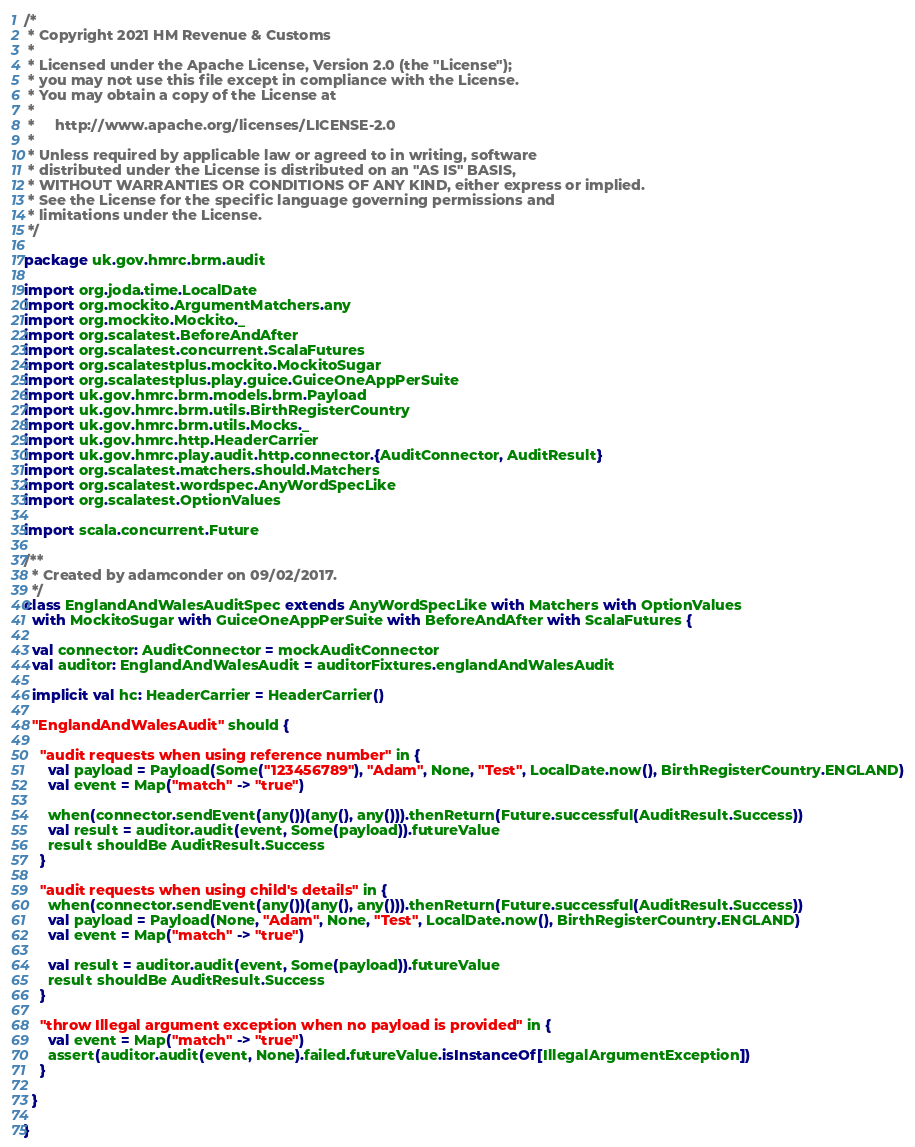Convert code to text. <code><loc_0><loc_0><loc_500><loc_500><_Scala_>/*
 * Copyright 2021 HM Revenue & Customs
 *
 * Licensed under the Apache License, Version 2.0 (the "License");
 * you may not use this file except in compliance with the License.
 * You may obtain a copy of the License at
 *
 *     http://www.apache.org/licenses/LICENSE-2.0
 *
 * Unless required by applicable law or agreed to in writing, software
 * distributed under the License is distributed on an "AS IS" BASIS,
 * WITHOUT WARRANTIES OR CONDITIONS OF ANY KIND, either express or implied.
 * See the License for the specific language governing permissions and
 * limitations under the License.
 */

package uk.gov.hmrc.brm.audit

import org.joda.time.LocalDate
import org.mockito.ArgumentMatchers.any
import org.mockito.Mockito._
import org.scalatest.BeforeAndAfter
import org.scalatest.concurrent.ScalaFutures
import org.scalatestplus.mockito.MockitoSugar
import org.scalatestplus.play.guice.GuiceOneAppPerSuite
import uk.gov.hmrc.brm.models.brm.Payload
import uk.gov.hmrc.brm.utils.BirthRegisterCountry
import uk.gov.hmrc.brm.utils.Mocks._
import uk.gov.hmrc.http.HeaderCarrier
import uk.gov.hmrc.play.audit.http.connector.{AuditConnector, AuditResult}
import org.scalatest.matchers.should.Matchers
import org.scalatest.wordspec.AnyWordSpecLike
import org.scalatest.OptionValues

import scala.concurrent.Future

/**
  * Created by adamconder on 09/02/2017.
  */
class EnglandAndWalesAuditSpec extends AnyWordSpecLike with Matchers with OptionValues
  with MockitoSugar with GuiceOneAppPerSuite with BeforeAndAfter with ScalaFutures {

  val connector: AuditConnector = mockAuditConnector
  val auditor: EnglandAndWalesAudit = auditorFixtures.englandAndWalesAudit

  implicit val hc: HeaderCarrier = HeaderCarrier()

  "EnglandAndWalesAudit" should {

    "audit requests when using reference number" in {
      val payload = Payload(Some("123456789"), "Adam", None, "Test", LocalDate.now(), BirthRegisterCountry.ENGLAND)
      val event = Map("match" -> "true")

      when(connector.sendEvent(any())(any(), any())).thenReturn(Future.successful(AuditResult.Success))
      val result = auditor.audit(event, Some(payload)).futureValue
      result shouldBe AuditResult.Success
    }

    "audit requests when using child's details" in {
      when(connector.sendEvent(any())(any(), any())).thenReturn(Future.successful(AuditResult.Success))
      val payload = Payload(None, "Adam", None, "Test", LocalDate.now(), BirthRegisterCountry.ENGLAND)
      val event = Map("match" -> "true")

      val result = auditor.audit(event, Some(payload)).futureValue
      result shouldBe AuditResult.Success
    }

    "throw Illegal argument exception when no payload is provided" in {
      val event = Map("match" -> "true")
      assert(auditor.audit(event, None).failed.futureValue.isInstanceOf[IllegalArgumentException])
    }

  }

}
</code> 